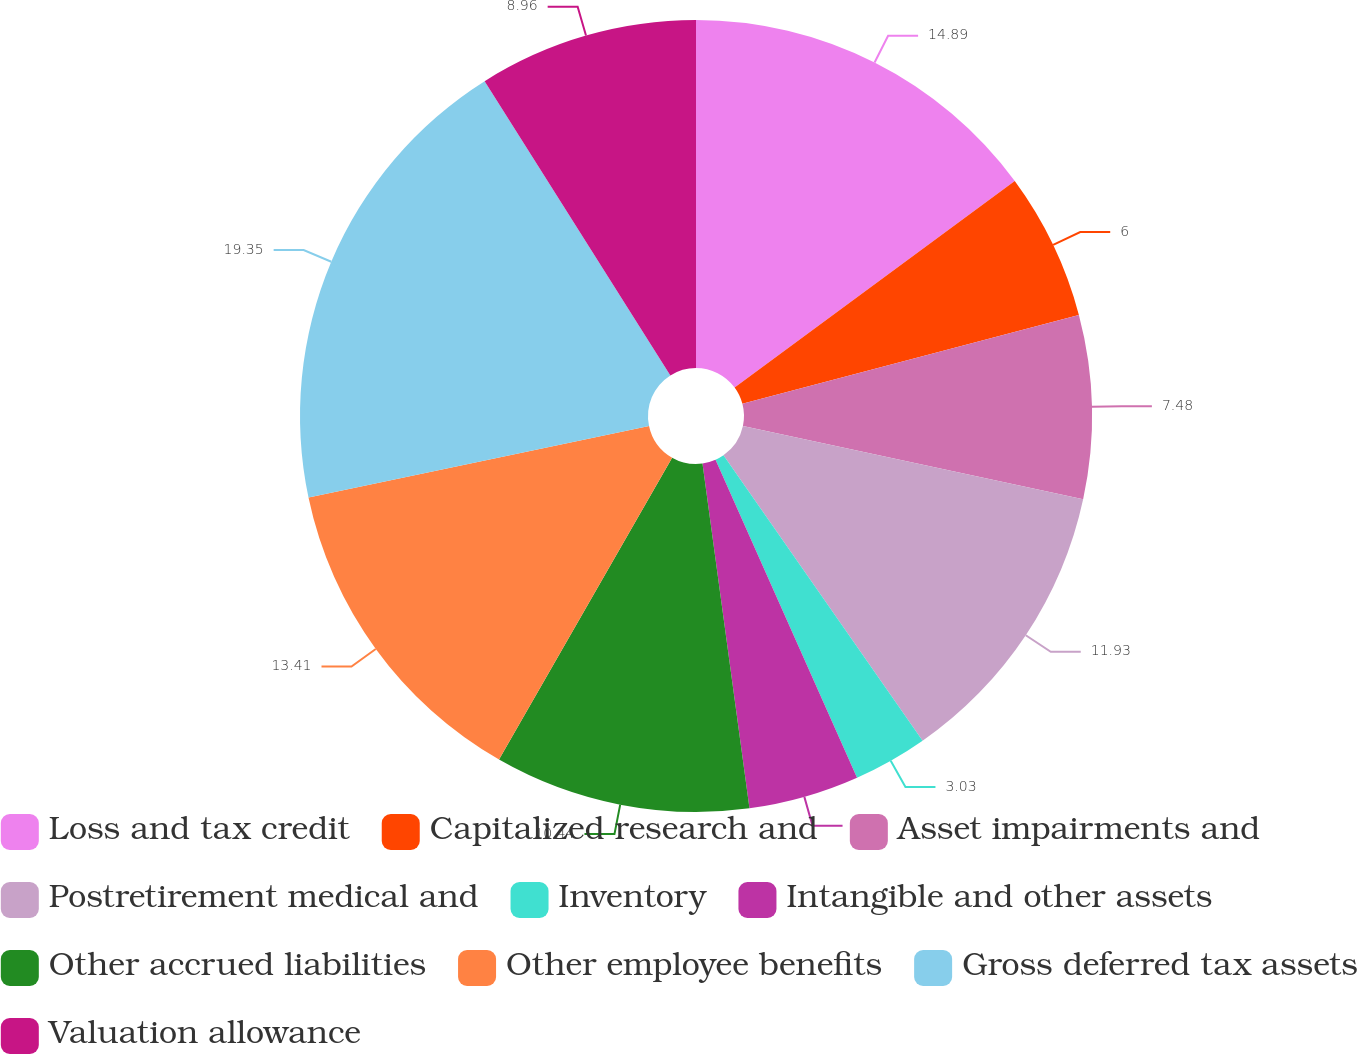Convert chart to OTSL. <chart><loc_0><loc_0><loc_500><loc_500><pie_chart><fcel>Loss and tax credit<fcel>Capitalized research and<fcel>Asset impairments and<fcel>Postretirement medical and<fcel>Inventory<fcel>Intangible and other assets<fcel>Other accrued liabilities<fcel>Other employee benefits<fcel>Gross deferred tax assets<fcel>Valuation allowance<nl><fcel>14.89%<fcel>6.0%<fcel>7.48%<fcel>11.93%<fcel>3.03%<fcel>4.51%<fcel>10.44%<fcel>13.41%<fcel>19.34%<fcel>8.96%<nl></chart> 